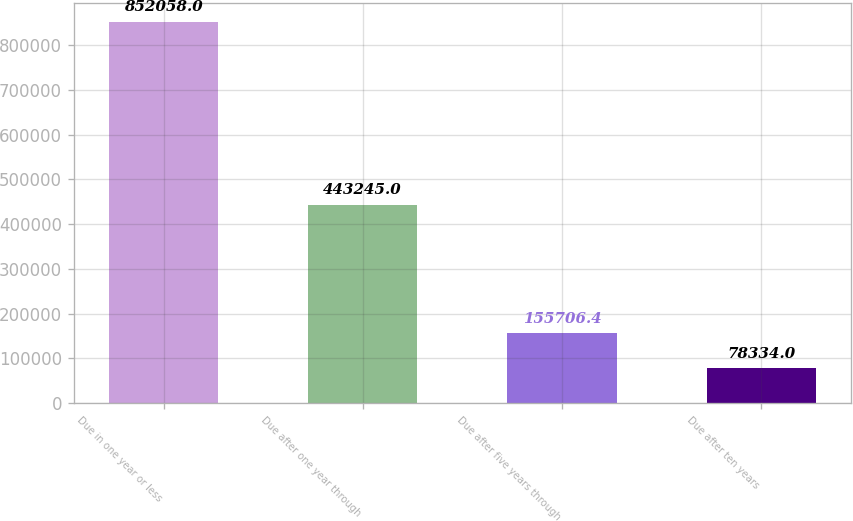Convert chart. <chart><loc_0><loc_0><loc_500><loc_500><bar_chart><fcel>Due in one year or less<fcel>Due after one year through<fcel>Due after five years through<fcel>Due after ten years<nl><fcel>852058<fcel>443245<fcel>155706<fcel>78334<nl></chart> 